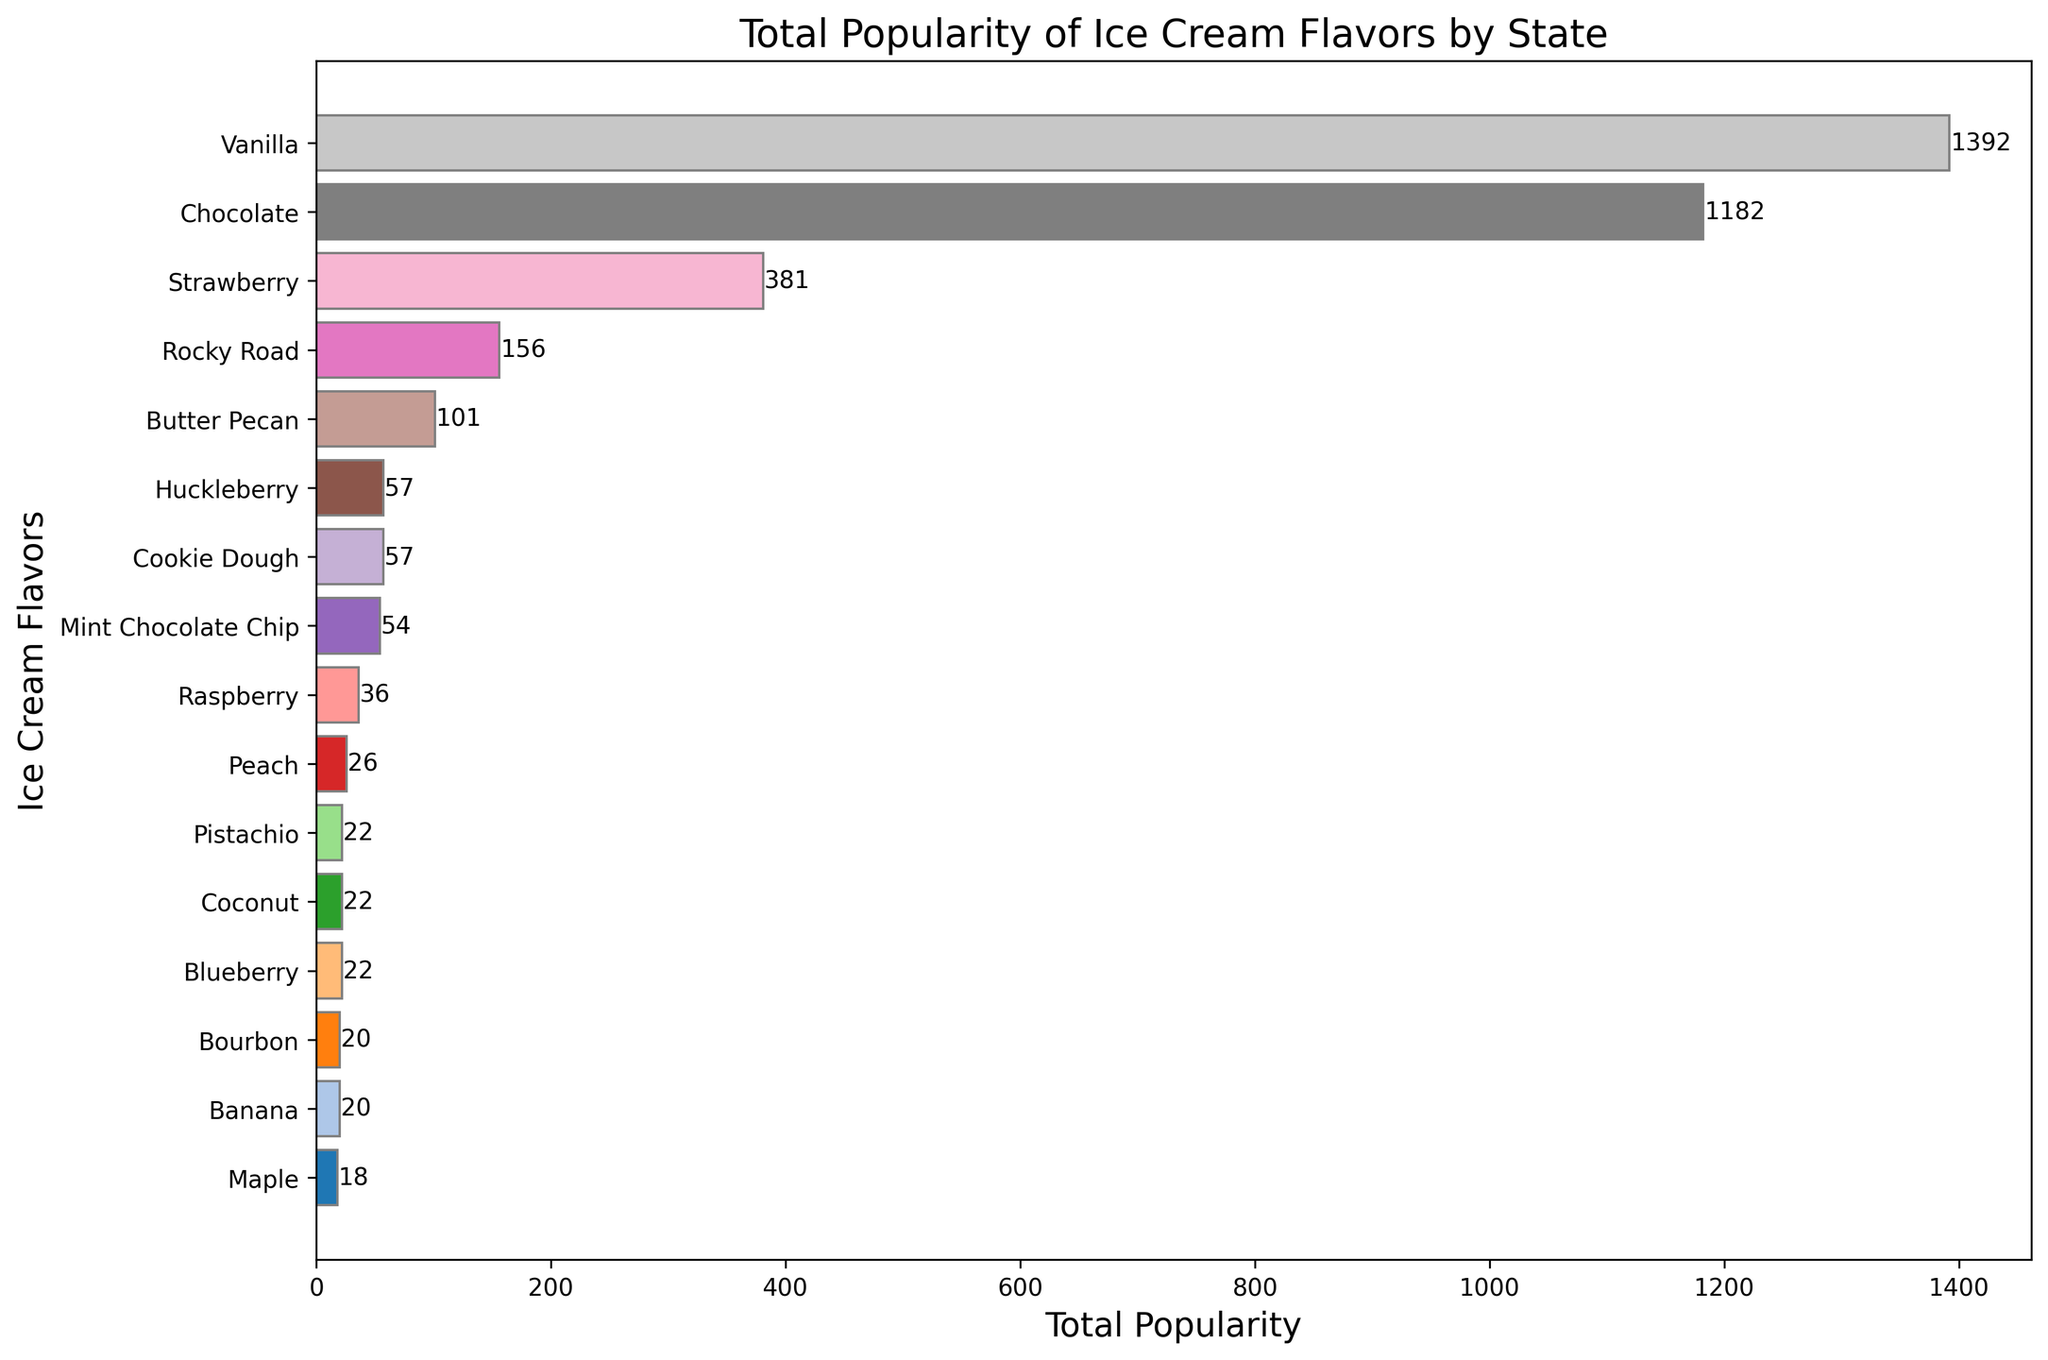Which ice cream flavor is the most popular overall? Look at the bar with the largest width in the horizontal bar chart. The flavor corresponding to this bar represents the most popular flavor.
Answer: Vanilla Which flavor is the least popular overall? Look at the bar with the smallest width in the chart. The flavor corresponding to this bar represents the least popular flavor.
Answer: Maple What's the total popularity of Vanilla and Chocolate combined? Find the popularity of Vanilla and Chocolate in the chart and sum them up. Vanilla's popularity is 1387, and Chocolate's is 1050. Adding these together: 1387 + 1050 = 2437.
Answer: 2437 Is Strawberry more popular than Mint Chocolate Chip? Compare the lengths of the bars for Strawberry and Mint Chocolate Chip. The bar for Strawberry is longer than Mint Chocolate Chip.
Answer: Yes How many ice cream flavors have a total popularity over 500? Count the number of bars whose lengths (popularity values) are greater than 500. There are 5 such flavors: Vanilla, Chocolate, Strawberry, Mint Chocolate Chip, and Rocky Road.
Answer: 5 Which flavor has the highest popularity outside the top 5 most popular flavors? Exclude the top 5 flavors (Vanilla, Chocolate, Strawberry, Mint Chocolate Chip, and Rocky Road), then find the longest bar among the remaining flavors. The flavor is Butter Pecan.
Answer: Butter Pecan What's the average popularity of all flavors? Sum the popularity values of all flavors and divide by the number of flavors. The total sum is (1387 + 1050 + 661 + 494 + 451 + 403 + 378 + 336 + 263 + 232 + 220 + 156 + 116 + 95 + 90 + 69) = 6351. There are 16 flavors, so the average is 6351 / 16 = 396.9375.
Answer: 396.94 Compare the popularity of Vanilla in California and Texas. Which state prefers Vanilla more? Look at the plot for the specific data: California's Vanilla popularity is 35, while Texas's Vanilla popularity is also 35. Therefore, preferences for Vanilla are the same in both states.
Answer: Both equal What's the difference in popularity between Rocky Road and Pistachio? Find the popularity of Rocky Road (451) and Pistachio (232) in the chart and find the difference: 451 - 232 = 219.
Answer: 219 